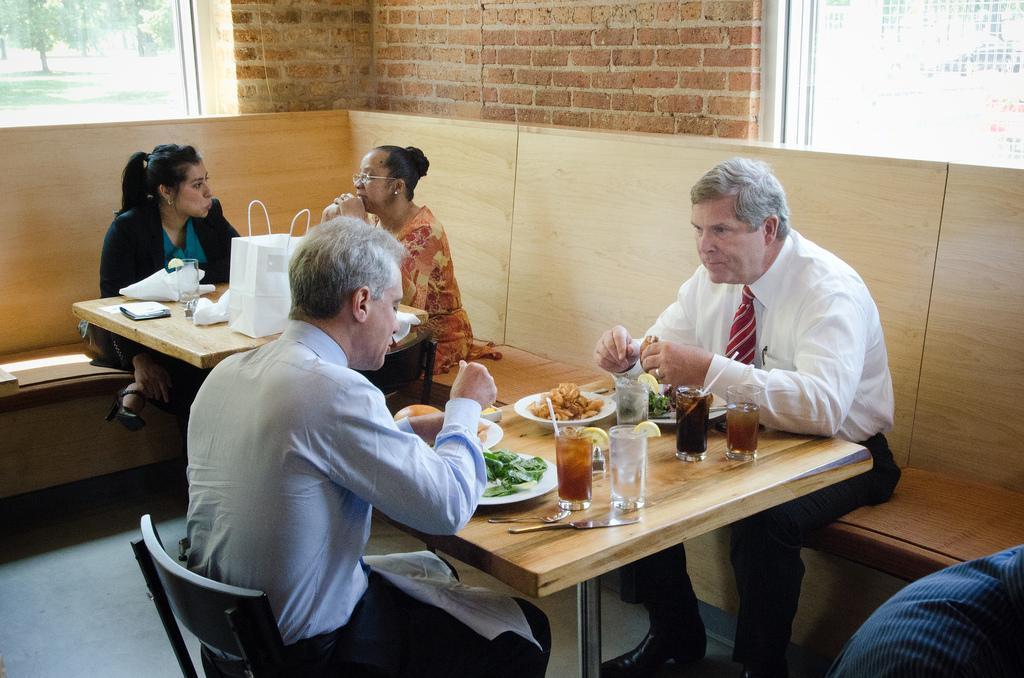How many people are seated in chairs?
Give a very brief answer. 1. 